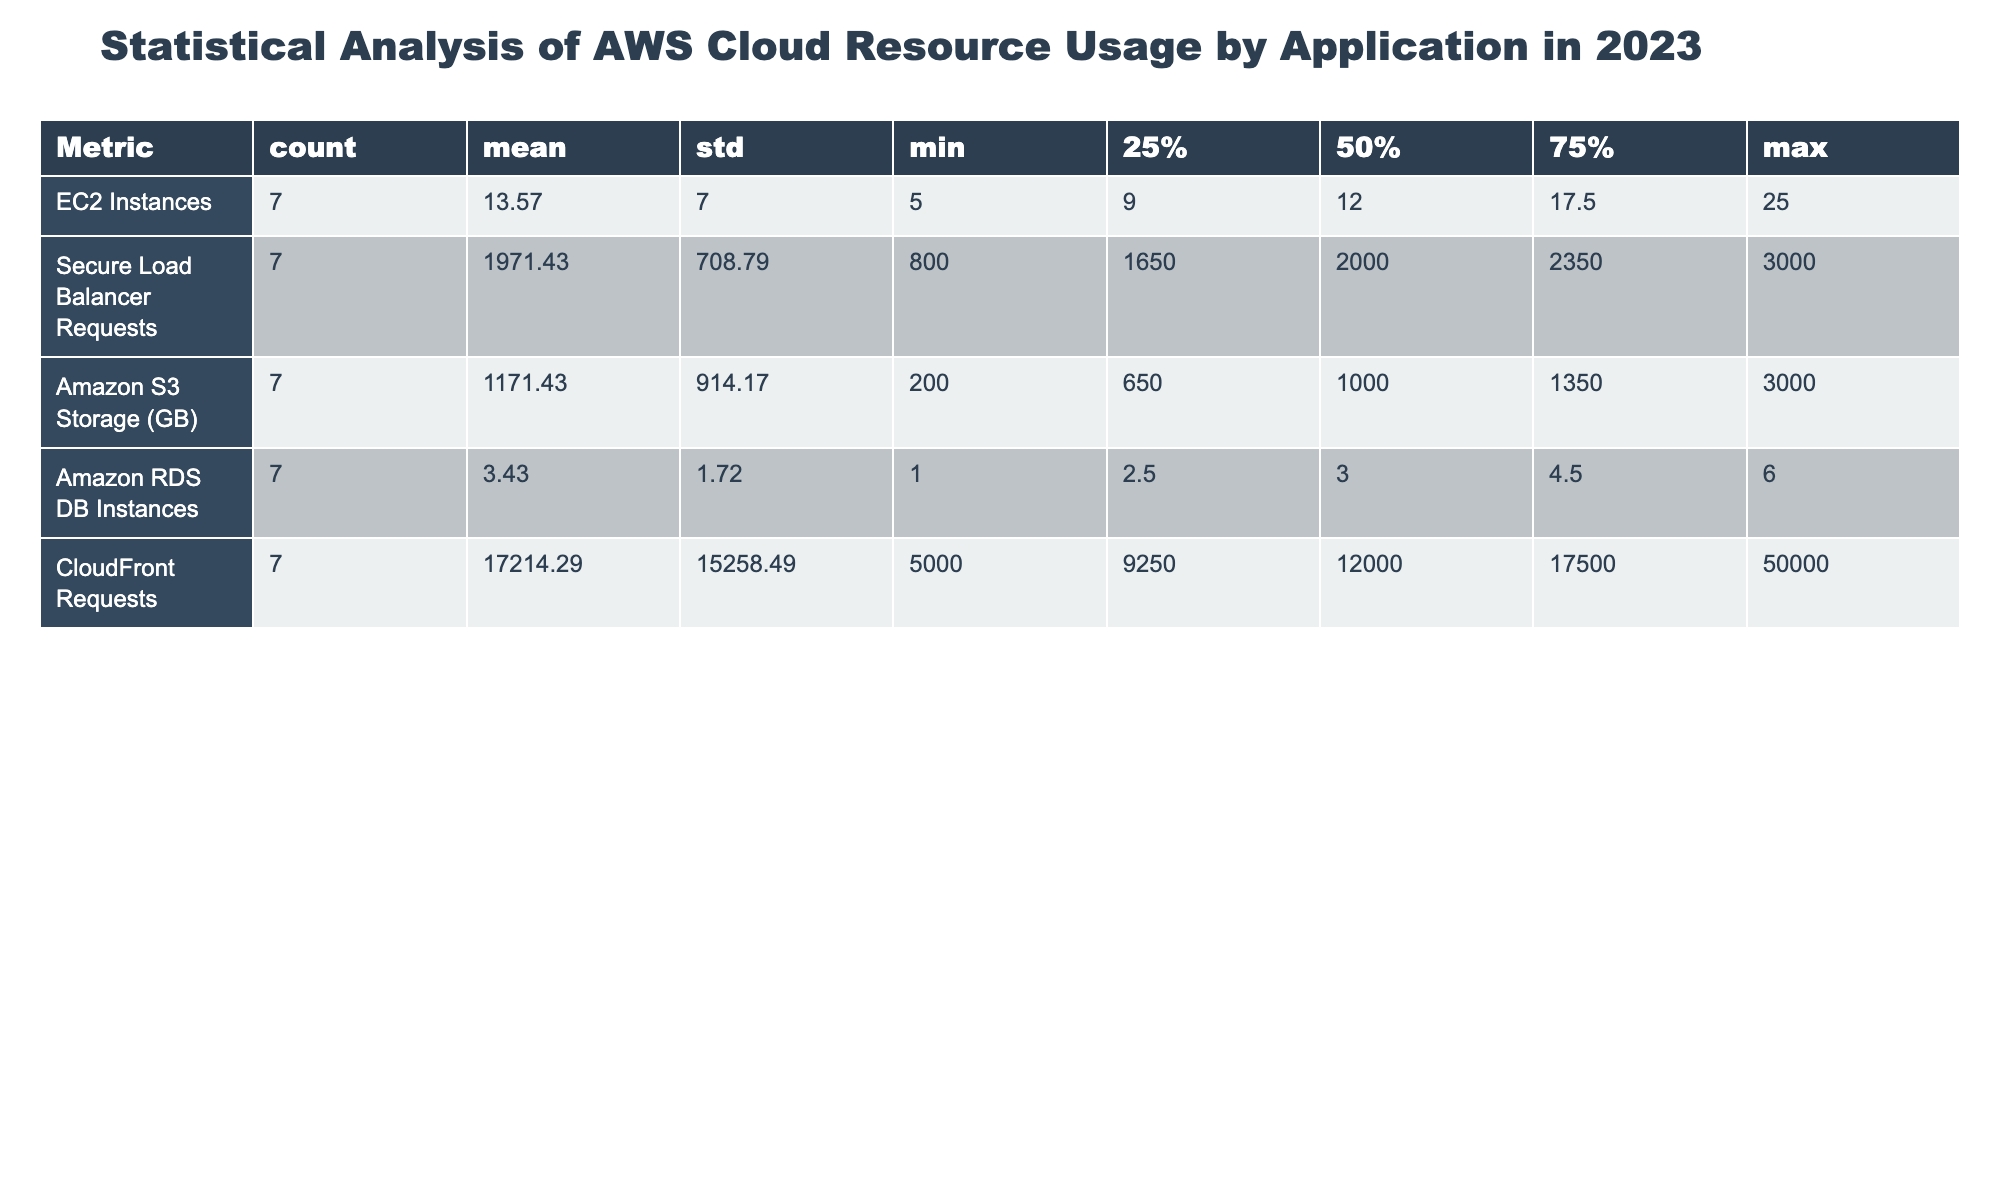What is the total number of EC2 instances used across all applications? Total EC2 instances can be calculated by summing up the EC2 instances for each application: 15 + 10 + 20 + 8 + 5 + 12 + 25 = 105.
Answer: 105 How much Amazon S3 storage is used by DataProcessingApp3? The table directly shows that DataProcessingApp3 uses 3000 GB of Amazon S3 storage.
Answer: 3000 GB Which application has the highest number of CloudFront requests? By examining the CloudFront requests column, GameServerApp7 shows the highest value, which is 50000 requests.
Answer: GameServerApp7 Is MachineLearningApp6 utilizing more Amazon RDS DB Instances than MobileApp2? MachineLearningApp6 has 3 RDS DB Instances while MobileApp2 has 2. Therefore, yes, MachineLearningApp6 utilizes more.
Answer: Yes What is the average number of Secure Load Balancer Requests per application? The average is calculated by summing the requests: (2000 + 1500 + 2500 + 1800 + 800 + 2200 + 3000) = 13800. Then divide by the number of applications (7): 13800 / 7 = 1971.43.
Answer: 1971.43 Which application has the lowest Amazon S3 storage usage? The lowest value in the Amazon S3 Storage column is for MicroserviceApp5, which uses 200 GB.
Answer: MicroserviceApp5 Are there more total Secure Load Balancer Requests than CloudFront Requests? First, calculate the total Secure Load Balancer Requests: 2000 + 1500 + 2500 + 1800 + 800 + 2200 + 3000 = 13800. Then calculate total CloudFront Requests: 15000 + 7500 + 20000 + 12000 + 5000 + 11000 + 50000 = 110500. Since 13800 < 110500, the answer is no.
Answer: No Which applications have more than 10 EC2 instances? Filtering through the table, WebApp1 (15), DataProcessingApp3 (20), GameServerApp7 (25) have more than 10 EC2 instances. Thus, the applications are WebApp1, DataProcessingApp3, and GameServerApp7.
Answer: WebApp1, DataProcessingApp3, GameServerApp7 